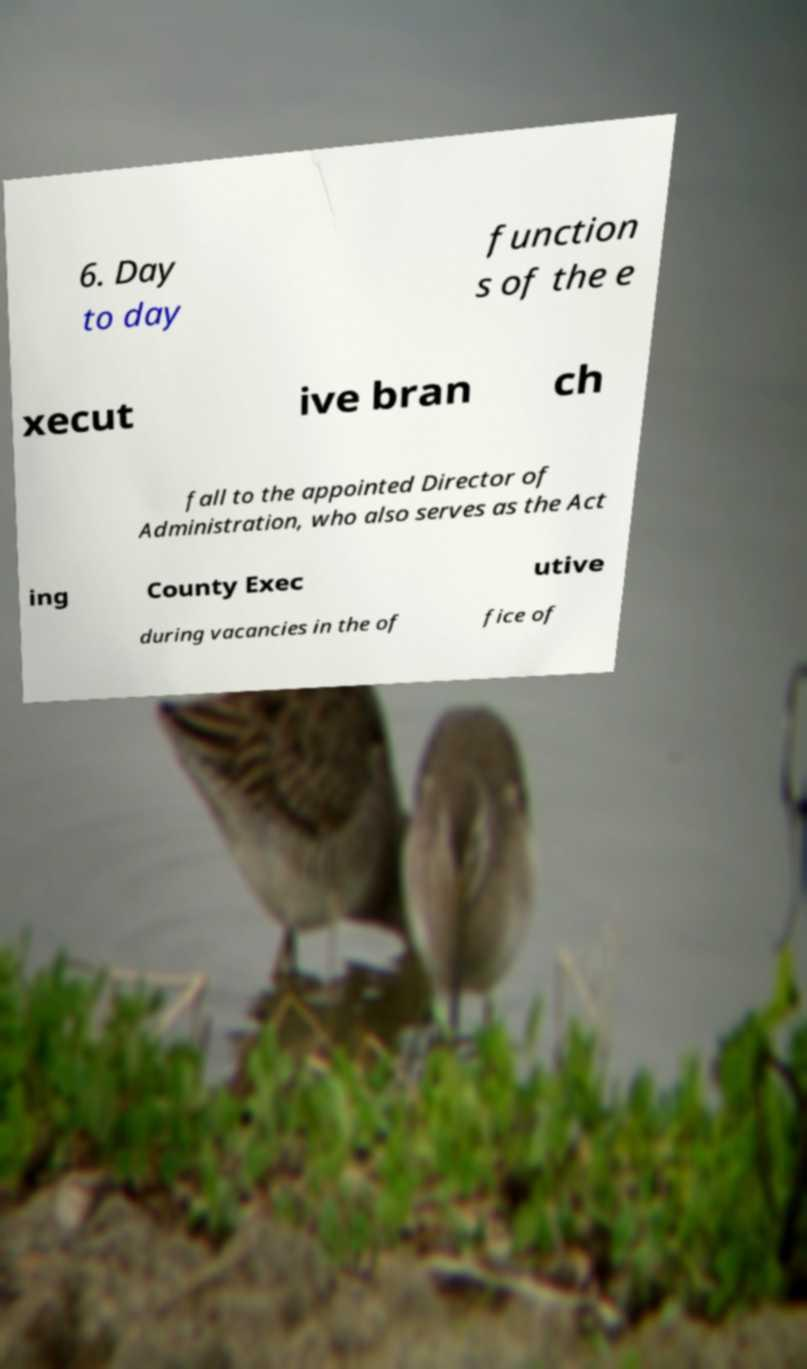There's text embedded in this image that I need extracted. Can you transcribe it verbatim? 6. Day to day function s of the e xecut ive bran ch fall to the appointed Director of Administration, who also serves as the Act ing County Exec utive during vacancies in the of fice of 